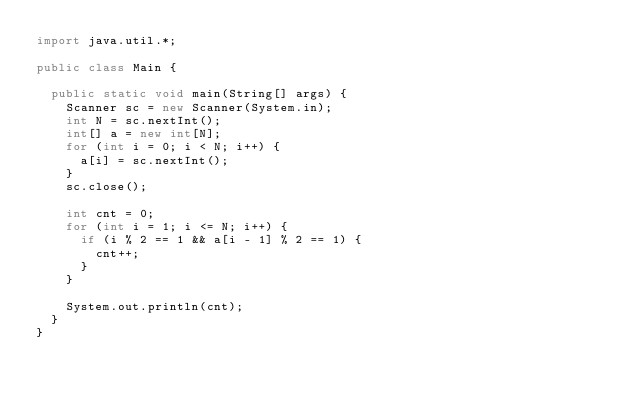<code> <loc_0><loc_0><loc_500><loc_500><_Java_>import java.util.*;

public class Main {

	public static void main(String[] args) {
		Scanner sc = new Scanner(System.in);
		int N = sc.nextInt();
		int[] a = new int[N];
		for (int i = 0; i < N; i++) {
			a[i] = sc.nextInt();
		}
		sc.close();

		int cnt = 0;
		for (int i = 1; i <= N; i++) {
			if (i % 2 == 1 && a[i - 1] % 2 == 1) {
				cnt++;
			}
		}

		System.out.println(cnt);
	}
}
</code> 